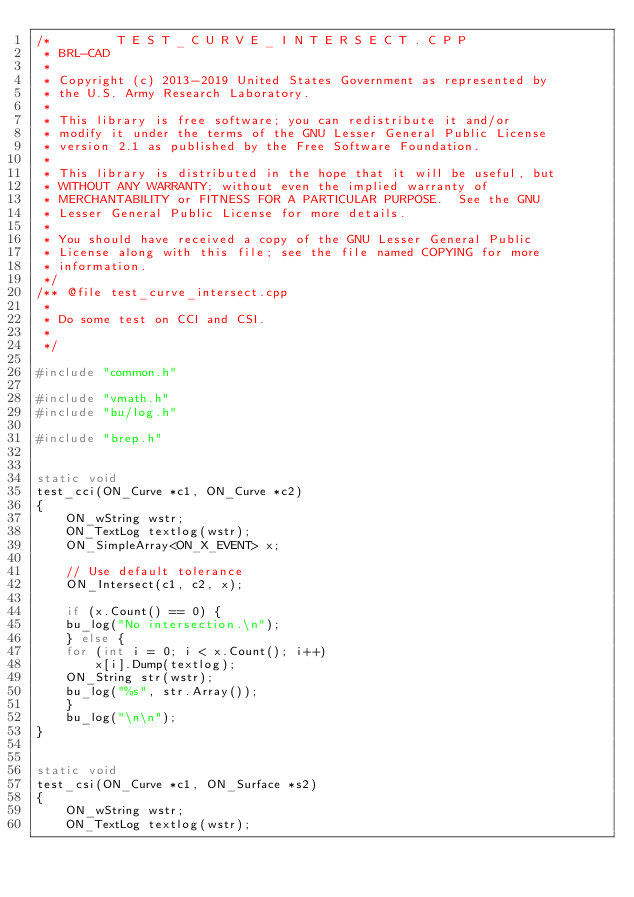<code> <loc_0><loc_0><loc_500><loc_500><_C++_>/*         T E S T _ C U R V E _ I N T E R S E C T . C P P
 * BRL-CAD
 *
 * Copyright (c) 2013-2019 United States Government as represented by
 * the U.S. Army Research Laboratory.
 *
 * This library is free software; you can redistribute it and/or
 * modify it under the terms of the GNU Lesser General Public License
 * version 2.1 as published by the Free Software Foundation.
 *
 * This library is distributed in the hope that it will be useful, but
 * WITHOUT ANY WARRANTY; without even the implied warranty of
 * MERCHANTABILITY or FITNESS FOR A PARTICULAR PURPOSE.  See the GNU
 * Lesser General Public License for more details.
 *
 * You should have received a copy of the GNU Lesser General Public
 * License along with this file; see the file named COPYING for more
 * information.
 */
/** @file test_curve_intersect.cpp
 *
 * Do some test on CCI and CSI.
 *
 */

#include "common.h"

#include "vmath.h"
#include "bu/log.h"

#include "brep.h"


static void
test_cci(ON_Curve *c1, ON_Curve *c2)
{
    ON_wString wstr;
    ON_TextLog textlog(wstr);
    ON_SimpleArray<ON_X_EVENT> x;

    // Use default tolerance
    ON_Intersect(c1, c2, x);

    if (x.Count() == 0) {
	bu_log("No intersection.\n");
    } else {
	for (int i = 0; i < x.Count(); i++)
	    x[i].Dump(textlog);
	ON_String str(wstr);
	bu_log("%s", str.Array());
    }
    bu_log("\n\n");
}


static void
test_csi(ON_Curve *c1, ON_Surface *s2)
{
    ON_wString wstr;
    ON_TextLog textlog(wstr);</code> 